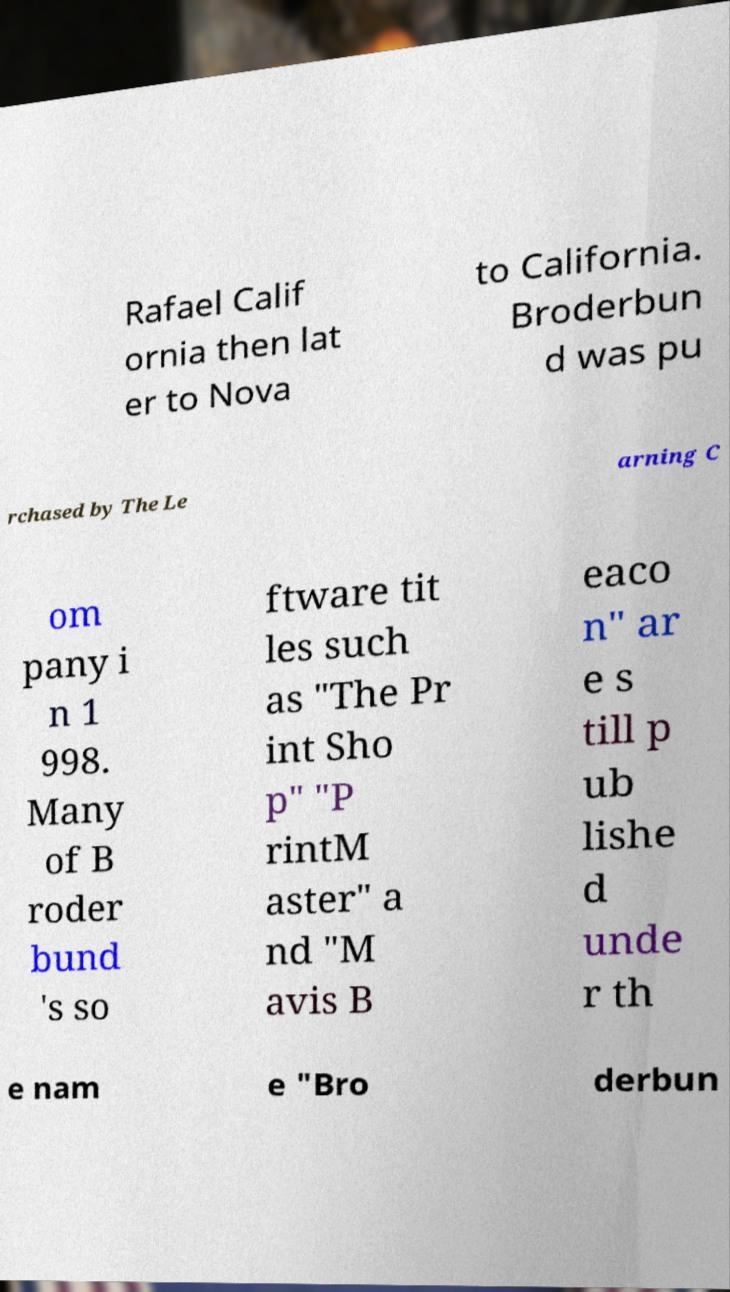Please read and relay the text visible in this image. What does it say? Rafael Calif ornia then lat er to Nova to California. Broderbun d was pu rchased by The Le arning C om pany i n 1 998. Many of B roder bund 's so ftware tit les such as "The Pr int Sho p" "P rintM aster" a nd "M avis B eaco n" ar e s till p ub lishe d unde r th e nam e "Bro derbun 